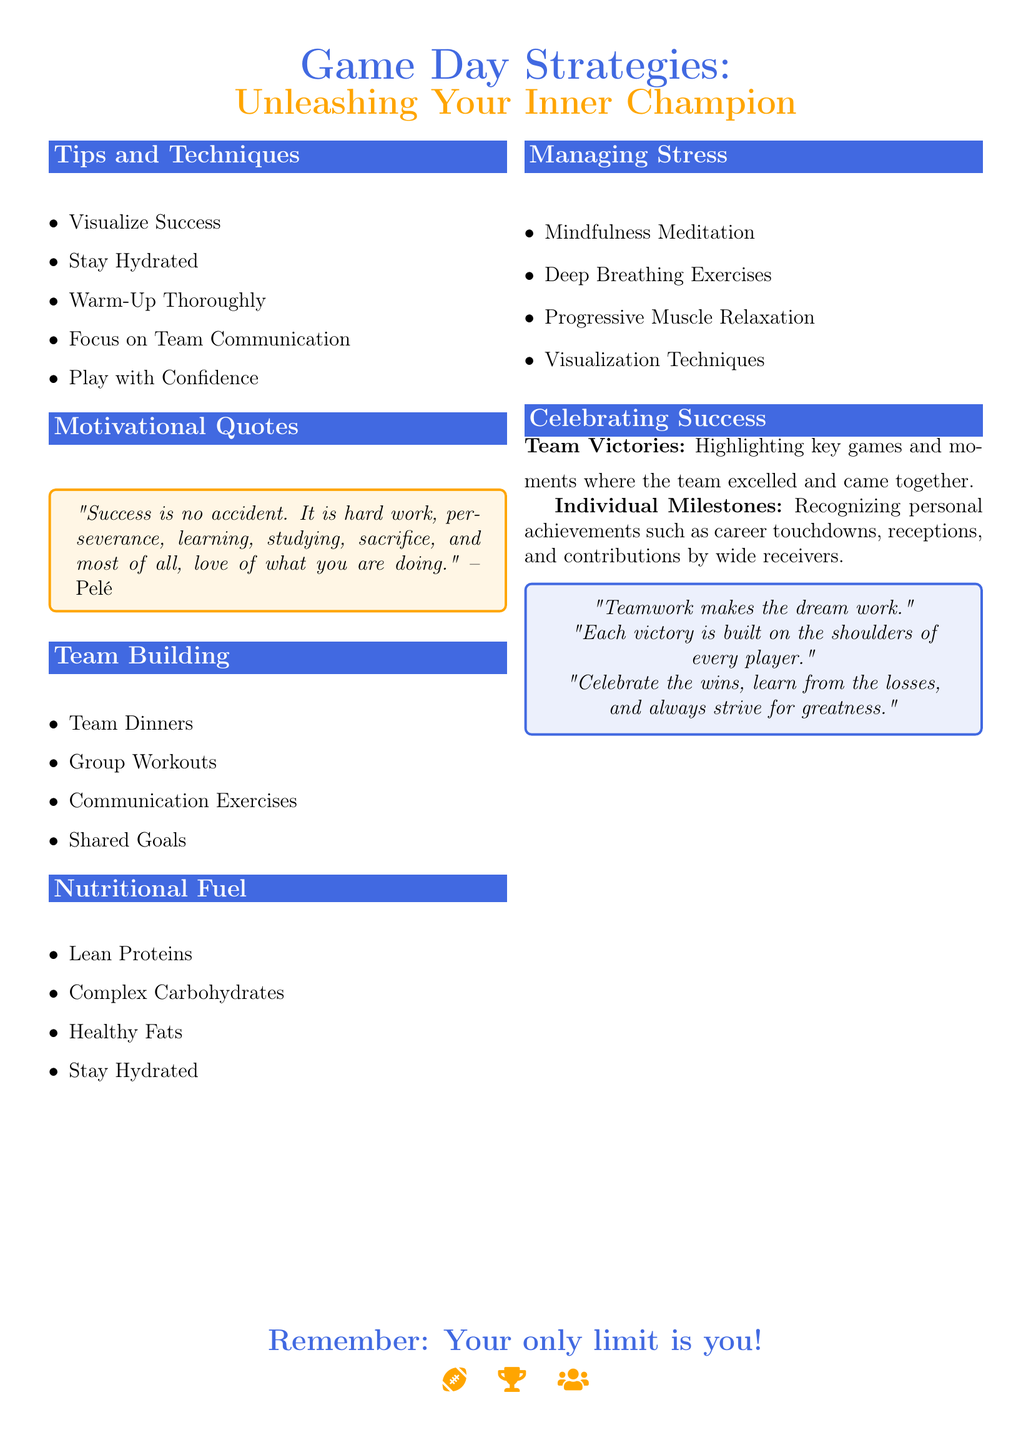What is the title of the first section? The title of the first section is "Tips and Techniques".
Answer: Tips and Techniques How many tips are listed under "Tips and Techniques"? There are five tips listed in the section.
Answer: 5 What food type is mentioned under "Nutritional Fuel"? The food types include lean proteins, complex carbohydrates, and healthy fats.
Answer: Lean Proteins What relaxation technique is suggested for managing stress? There are multiple techniques; one example is mindfulness meditation.
Answer: Mindfulness Meditation Which motivational quote is included in the document? The quote by Pelé emphasizes the values of hard work and perseverance.
Answer: "Success is no accident..." What does the document highlight about individual achievements? It recognizes personal achievements such as career touchdowns and receptions.
Answer: Personal achievements How does the document define the importance of teamwork? It states that teamwork is crucial for achieving victories and creating a supportive environment.
Answer: Teamwork makes the dream work What is the primary focus of the "Managing Stress" section? The section provides techniques for athletes to manage stress and anxiety.
Answer: Techniques for managing stress What color is used for the primary background in the flyer? The main color specified in the document is a shade of blue.
Answer: Blue 